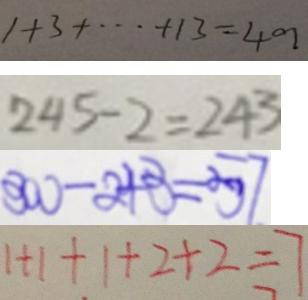<formula> <loc_0><loc_0><loc_500><loc_500>1 + 3 + \cdots + 1 3 = 4 9 
 2 4 5 - 2 = 2 4 3 
 3 0 0 - 2 4 3 = 5 7 
 1 + 1 + 1 + 2 + 2 = 7</formula> 